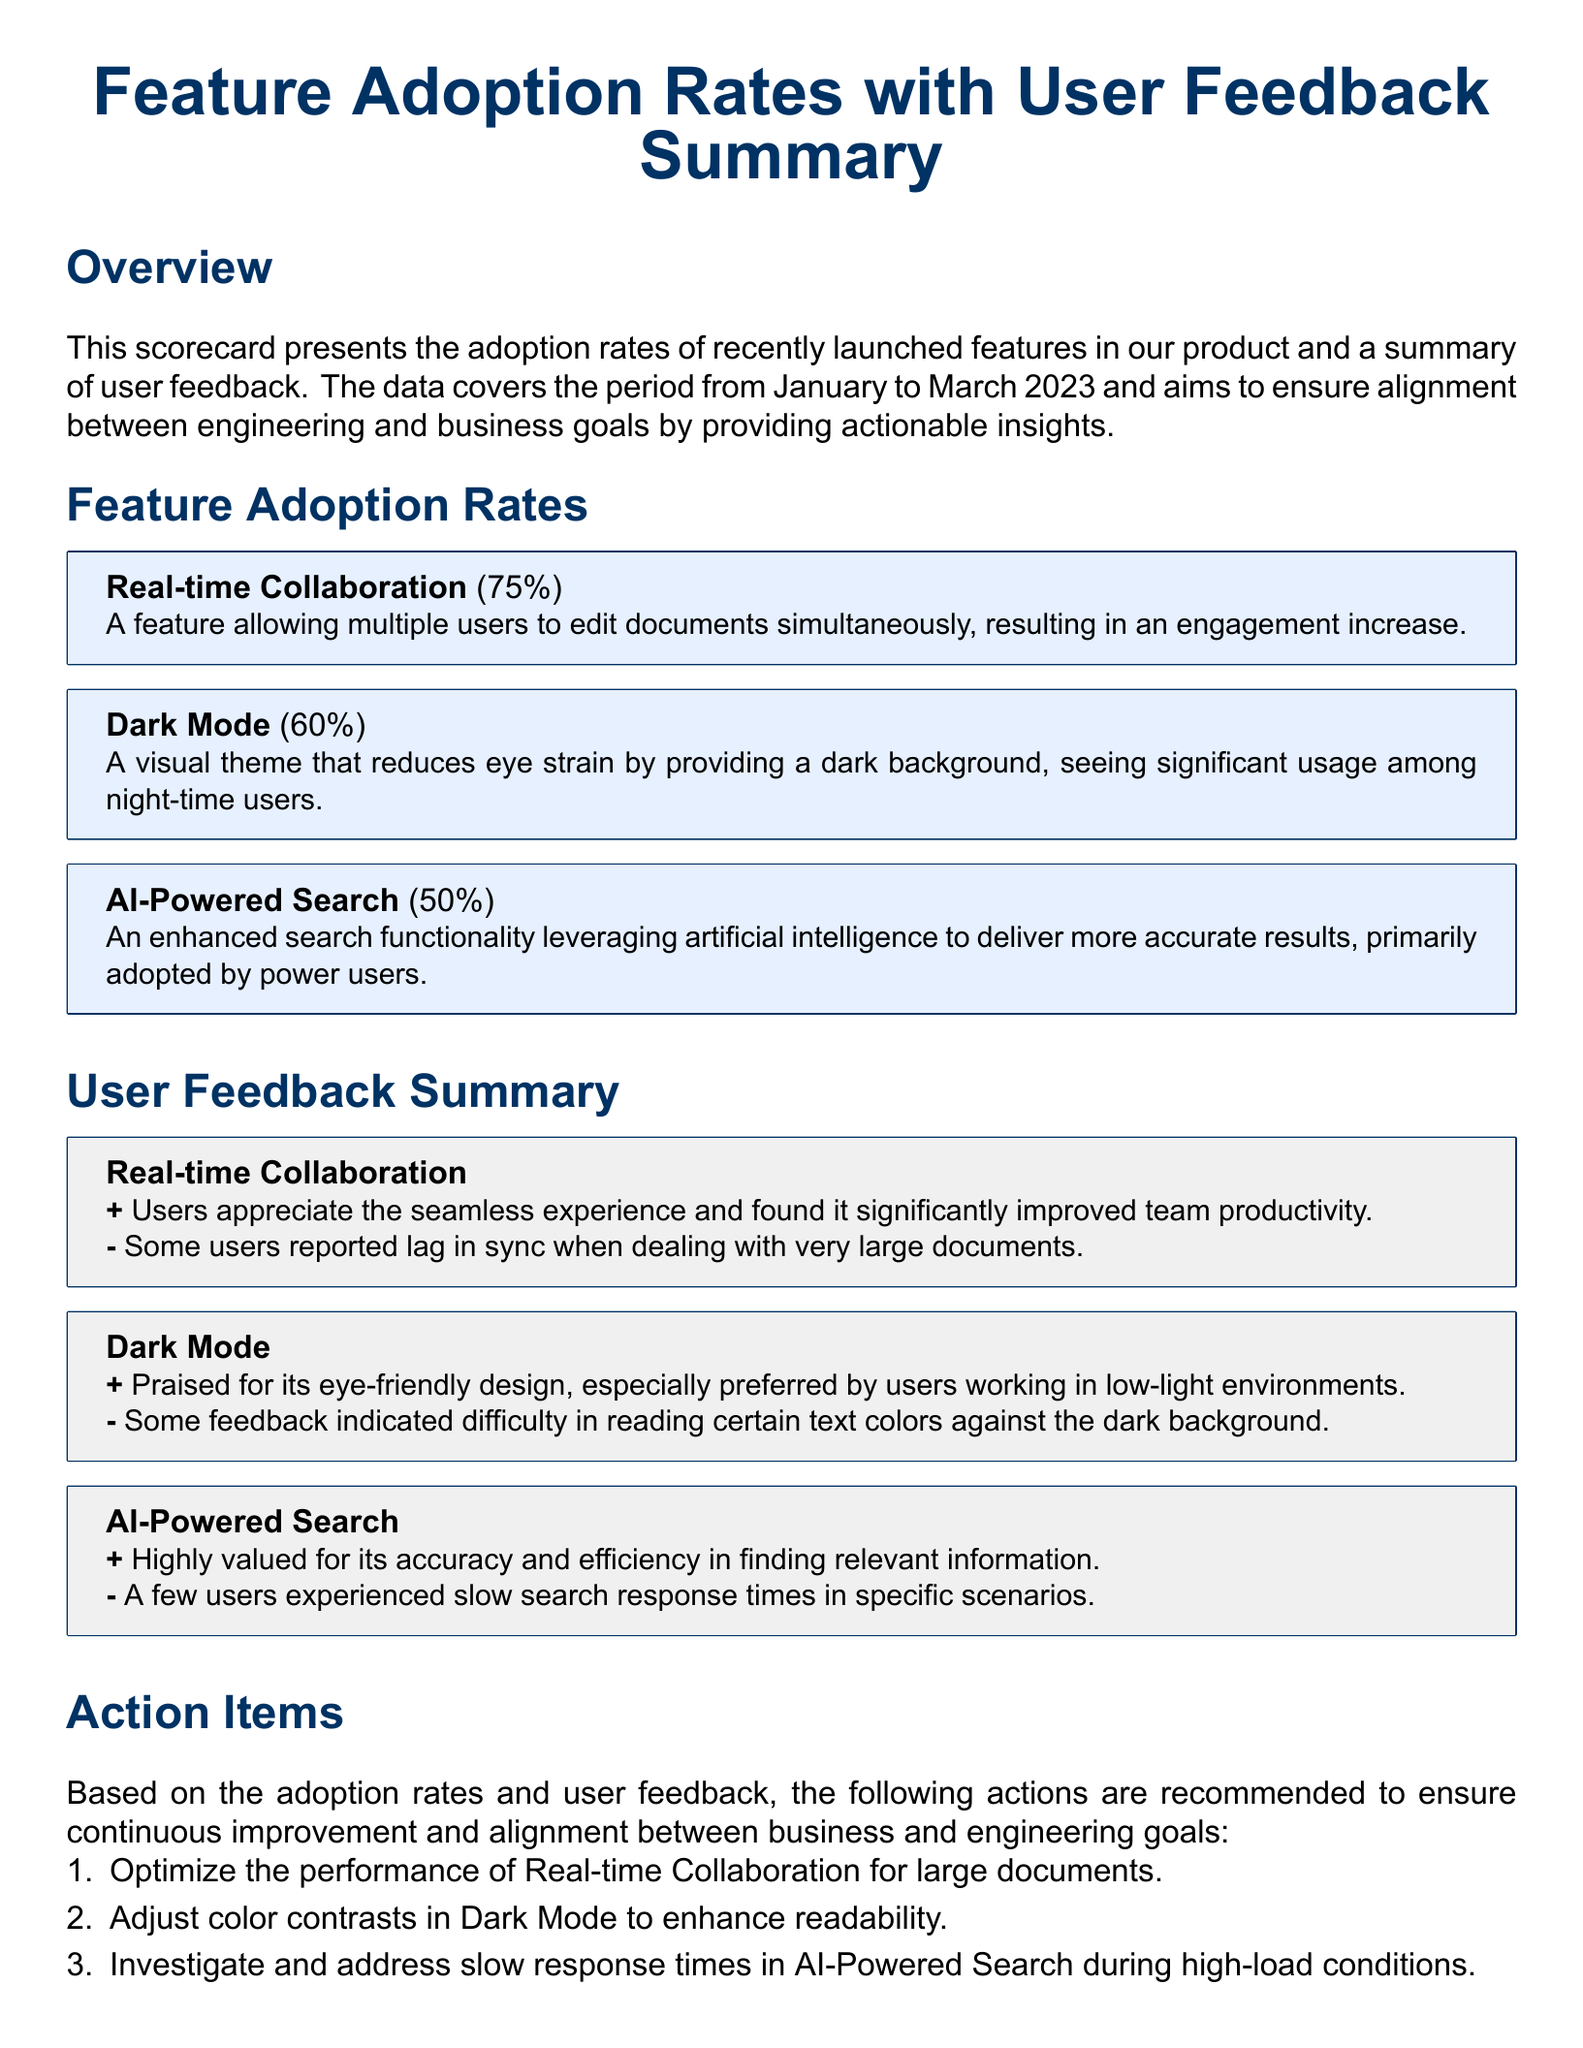What is the adoption rate of Real-time Collaboration? The adoption rate of Real-time Collaboration is explicitly stated in the document as 75%.
Answer: 75% What user group primarily adopted the AI-Powered Search feature? The document specifies that AI-Powered Search is primarily adopted by power users.
Answer: power users What action is recommended for the Dark Mode feature? The document recommends adjusting color contrasts in Dark Mode to enhance readability.
Answer: Adjust color contrasts What percentage of users adopted Dark Mode? Dark Mode has an adoption rate reported in the document as 60%.
Answer: 60% What feedback did users provide regarding the AI-Powered Search? Users highly valued AI-Powered Search for its accuracy and efficiency in finding relevant information.
Answer: Accuracy and efficiency What issue did users experience with Real-time Collaboration? The document mentions that some users reported lag in sync when dealing with very large documents.
Answer: Lag in sync How many features are listed in the Feature Adoption Rates section? The Feature Adoption Rates section lists three features.
Answer: Three What is the overall purpose of this scorecard? The overview section states that the scorecard aims to ensure alignment between engineering and business goals by providing actionable insights.
Answer: Alignment between engineering and business goals Which feature received feedback about text color readability? Users provided feedback on Dark Mode indicating difficulty in reading certain text colors against the dark background.
Answer: Dark Mode 